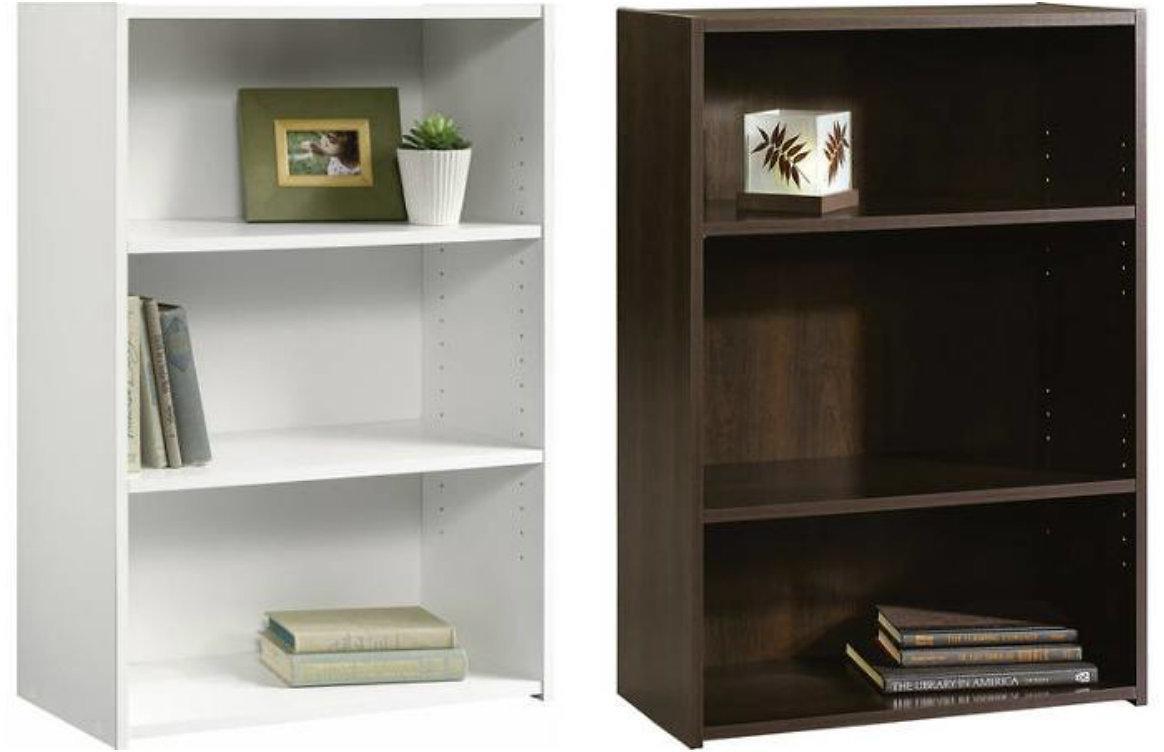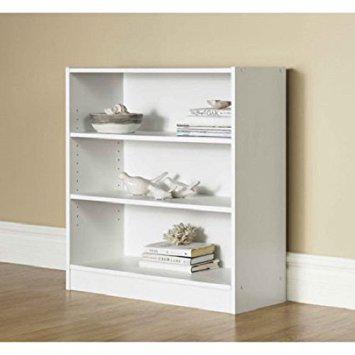The first image is the image on the left, the second image is the image on the right. Analyze the images presented: Is the assertion "One of the bookshelves is not white." valid? Answer yes or no. Yes. The first image is the image on the left, the second image is the image on the right. Given the left and right images, does the statement "All shelf units shown are white, and all shelf units contain some books on some shelves." hold true? Answer yes or no. No. 